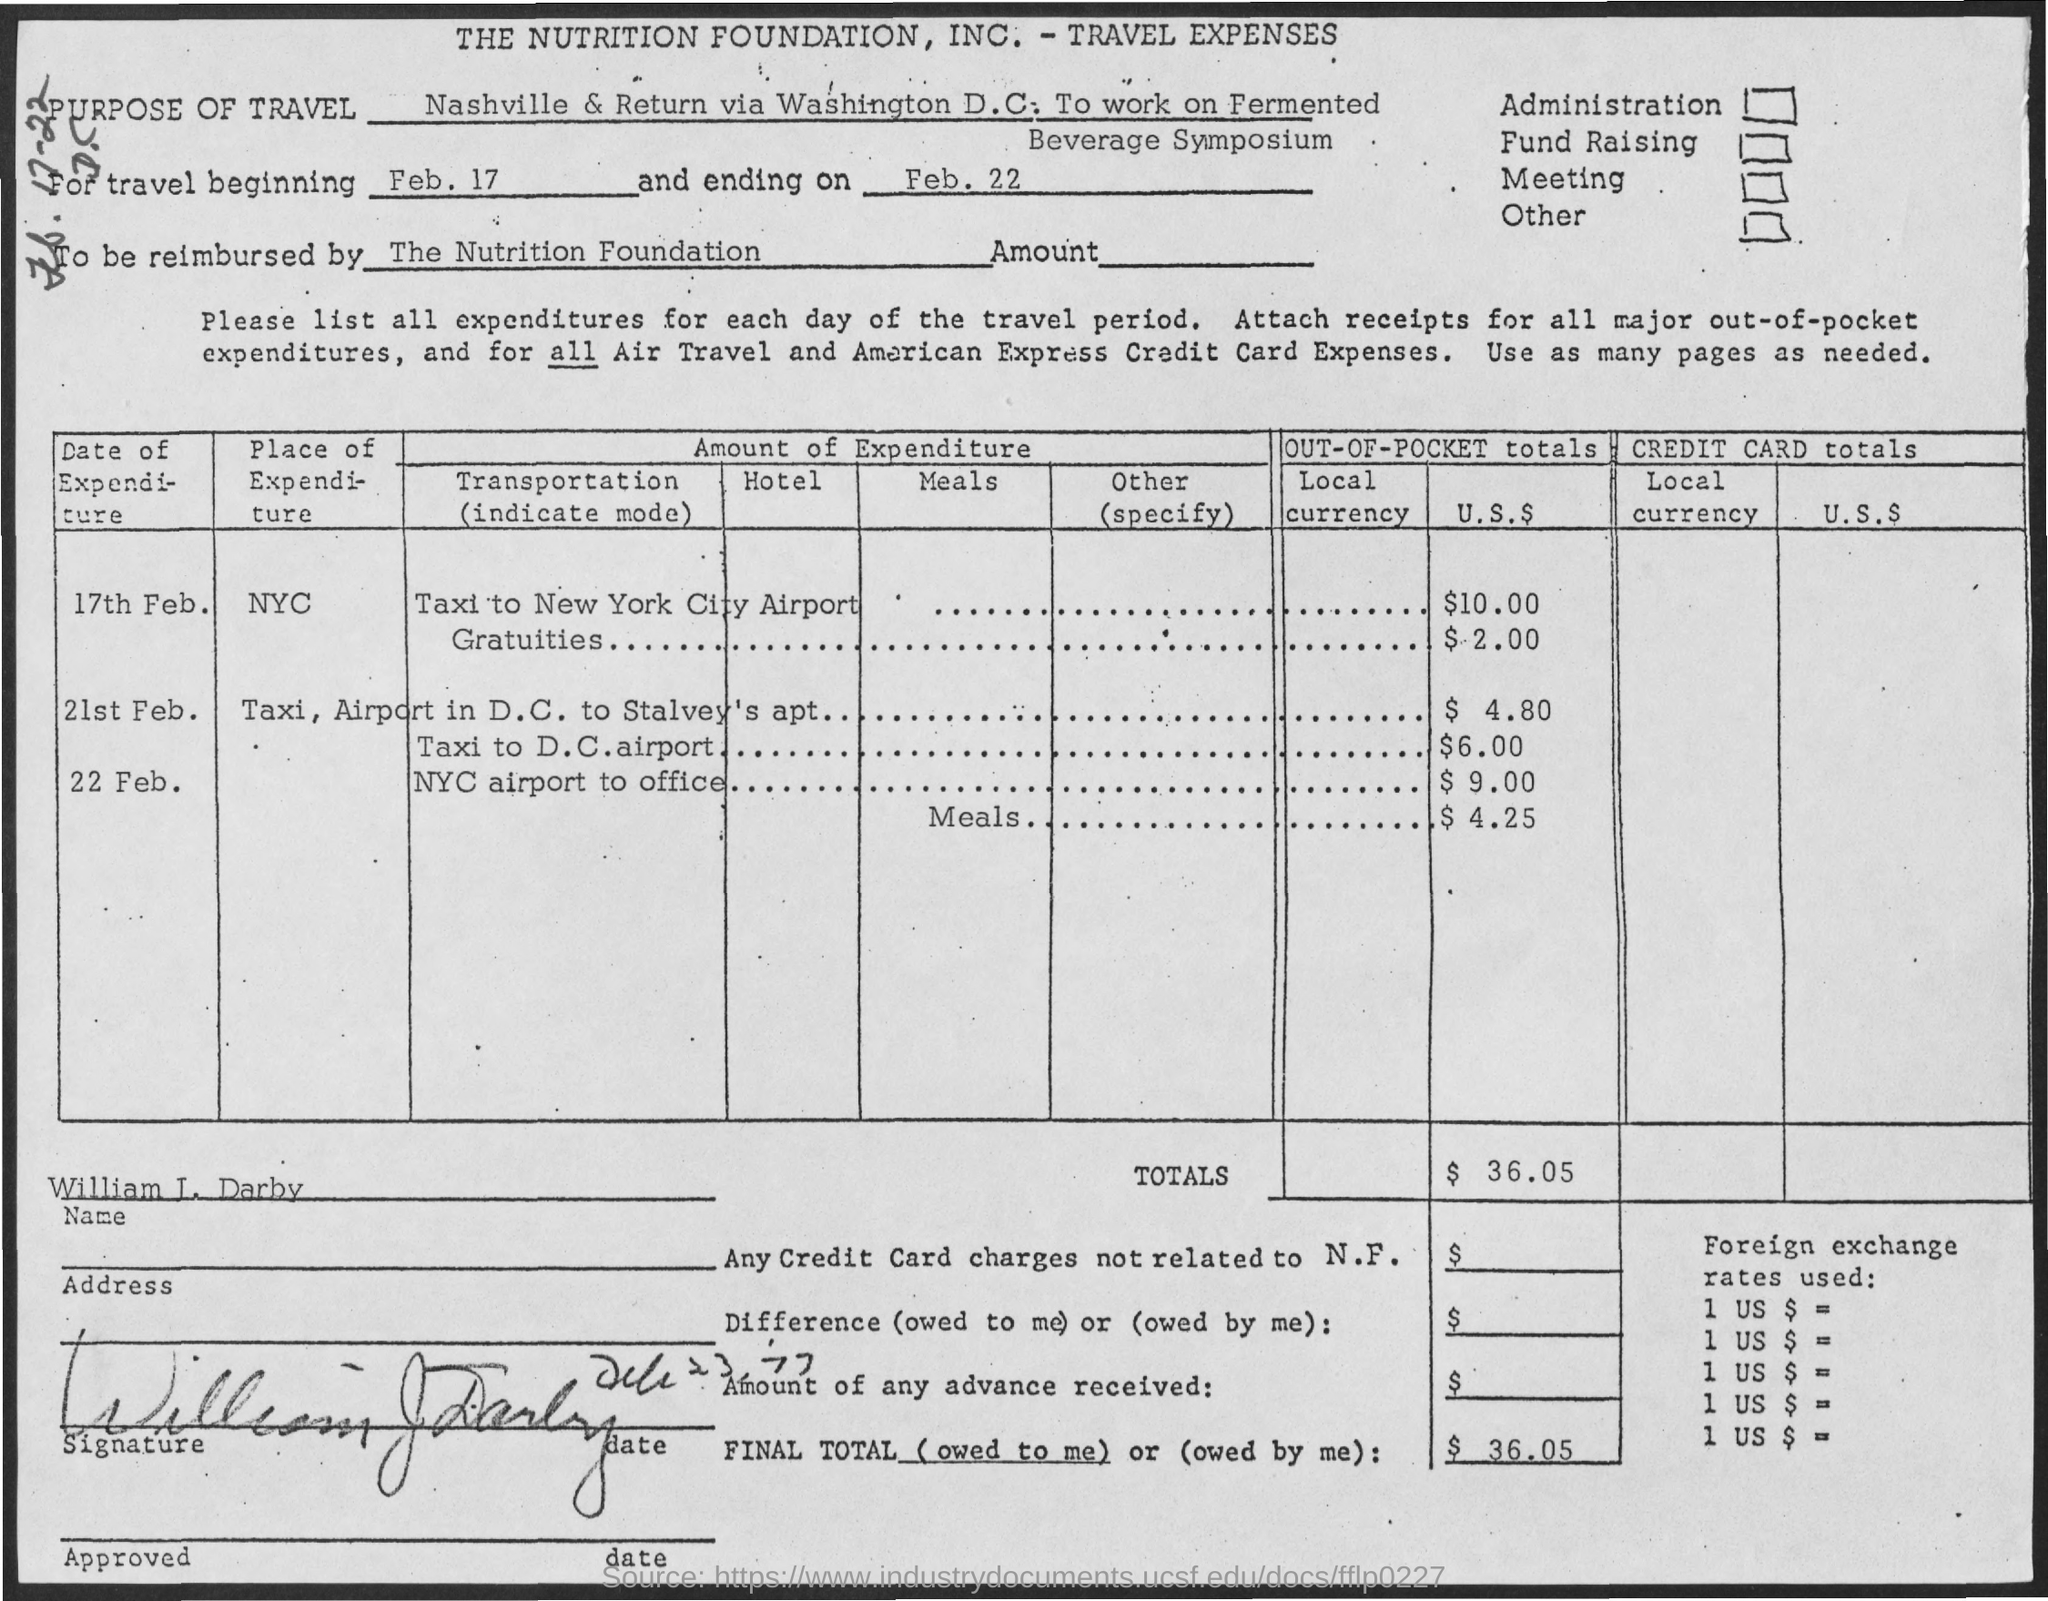What is the travel ending date ?
Offer a terse response. FEB, 22. 